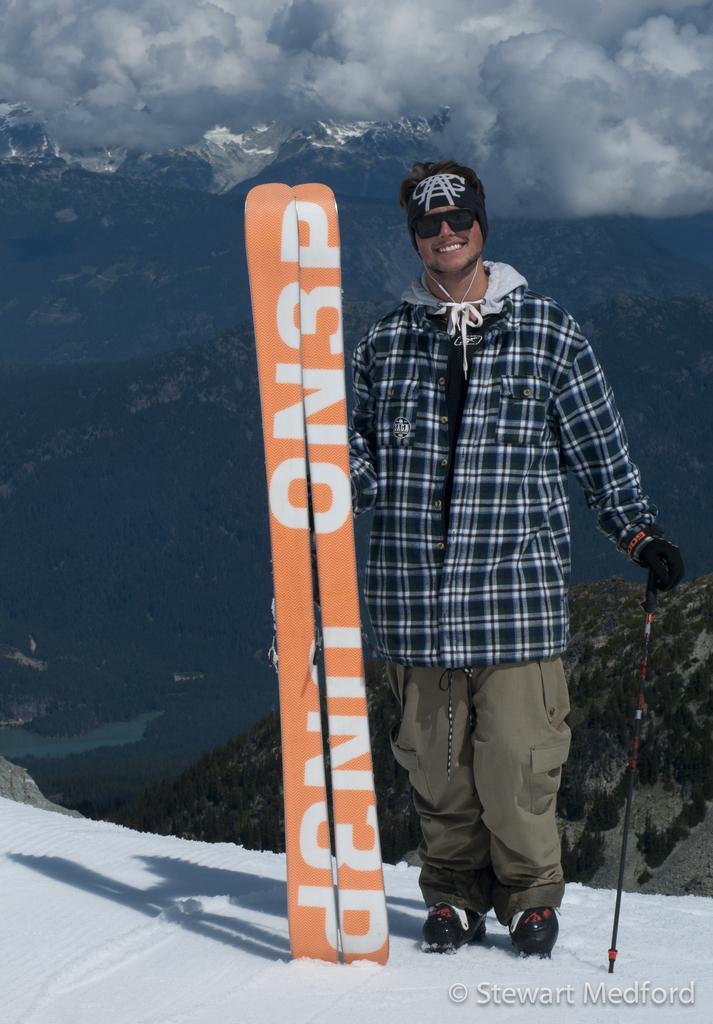Describe this image in one or two sentences. In the image there is a man holding a trekking kit with his hands and he is smiling for the photograph. 